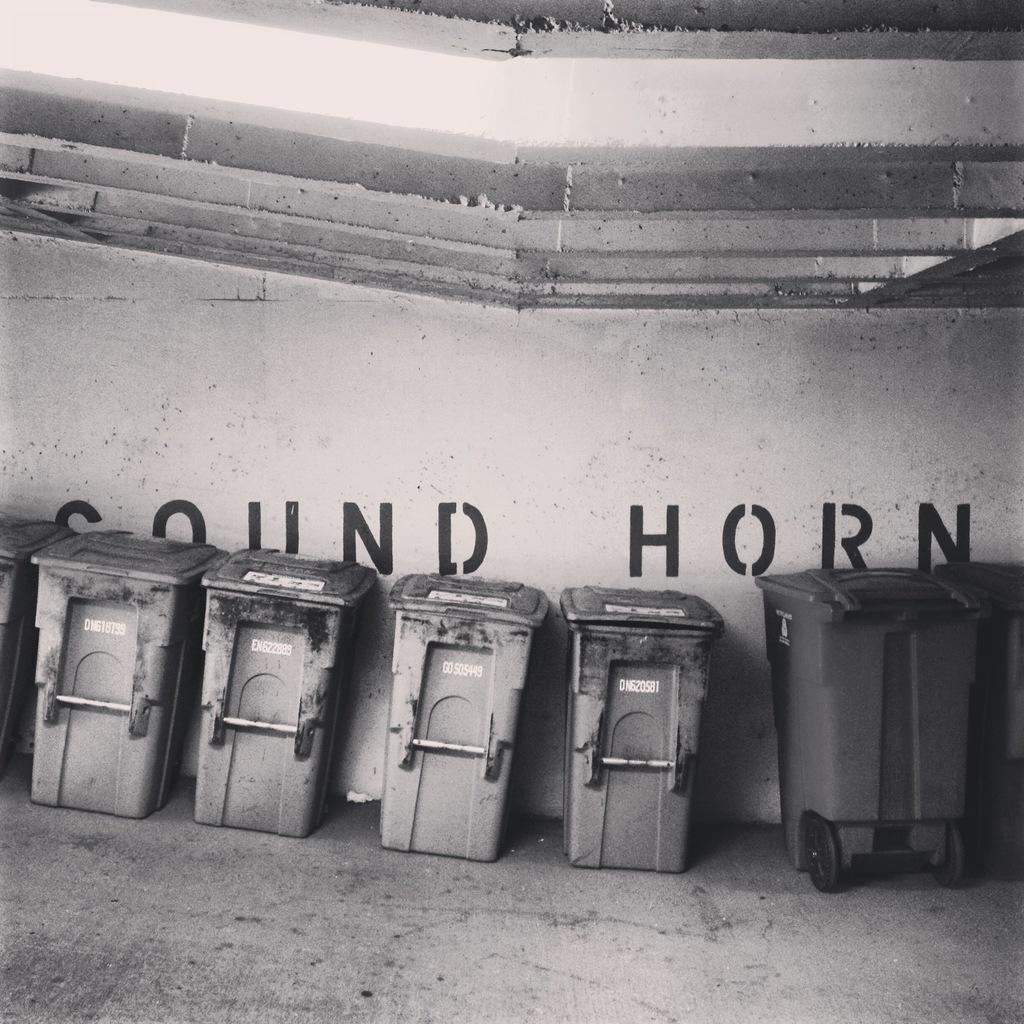<image>
Provide a brief description of the given image. Garbage pails are lined up in front of a wall that says sound horn on it. 